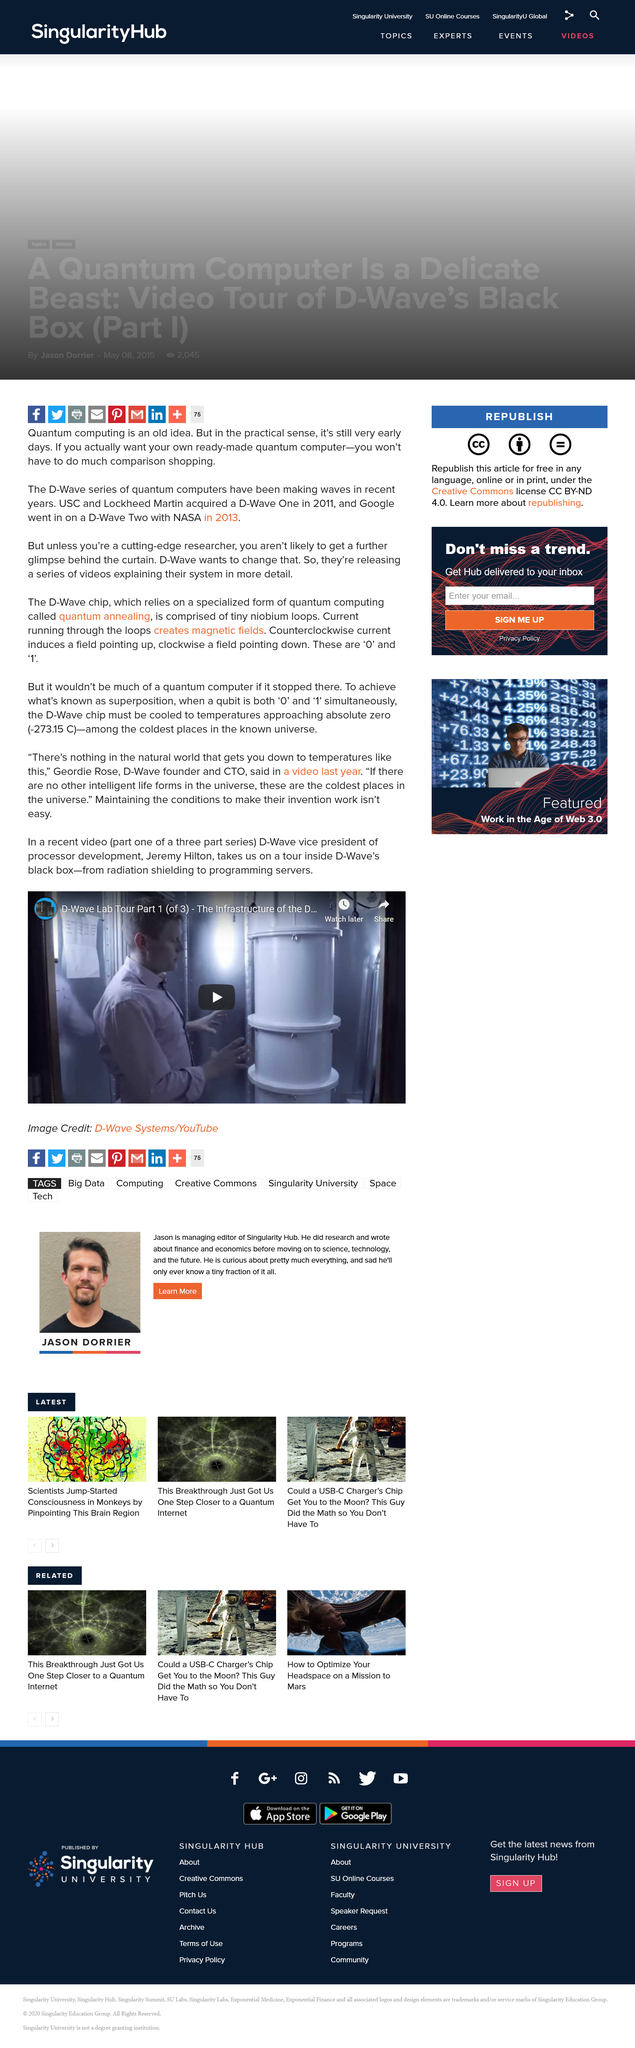Give some essential details in this illustration. Jeremy Hilton is the Vice President of Processor Development at D-Wave, a company that specializes in the development of quantum computing technology. The D-Wave chip must be cooled to temperatures approaching absolute zero in order to achieve superposition. Geordie Rose is the founder of D-Wave. 